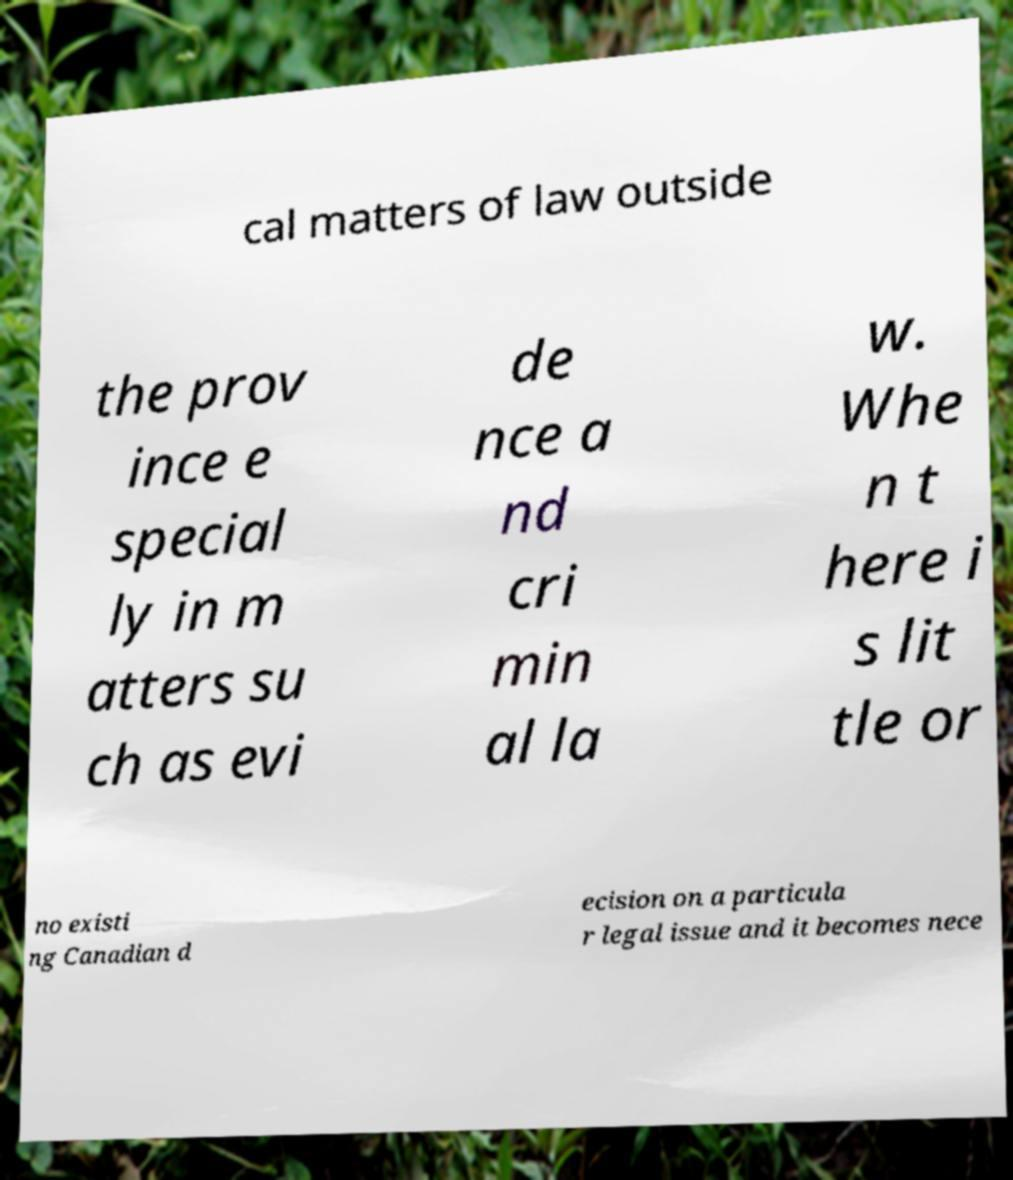Could you assist in decoding the text presented in this image and type it out clearly? cal matters of law outside the prov ince e special ly in m atters su ch as evi de nce a nd cri min al la w. Whe n t here i s lit tle or no existi ng Canadian d ecision on a particula r legal issue and it becomes nece 